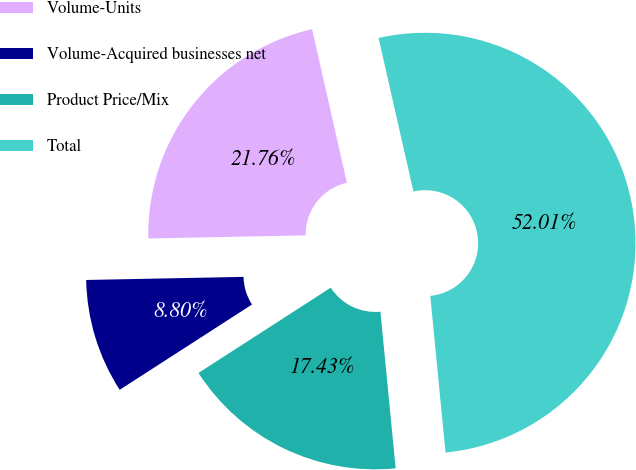<chart> <loc_0><loc_0><loc_500><loc_500><pie_chart><fcel>Volume-Units<fcel>Volume-Acquired businesses net<fcel>Product Price/Mix<fcel>Total<nl><fcel>21.76%<fcel>8.8%<fcel>17.43%<fcel>52.01%<nl></chart> 